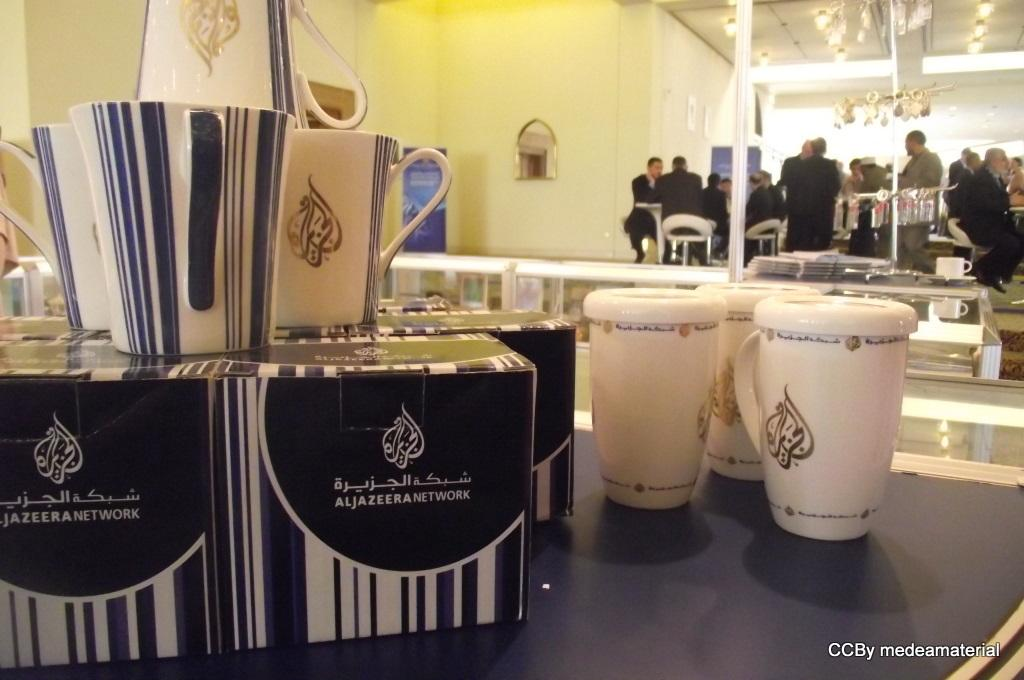<image>
Summarize the visual content of the image. Three cups on top of a table next to some black boxes that say "Aljazeera Network". 